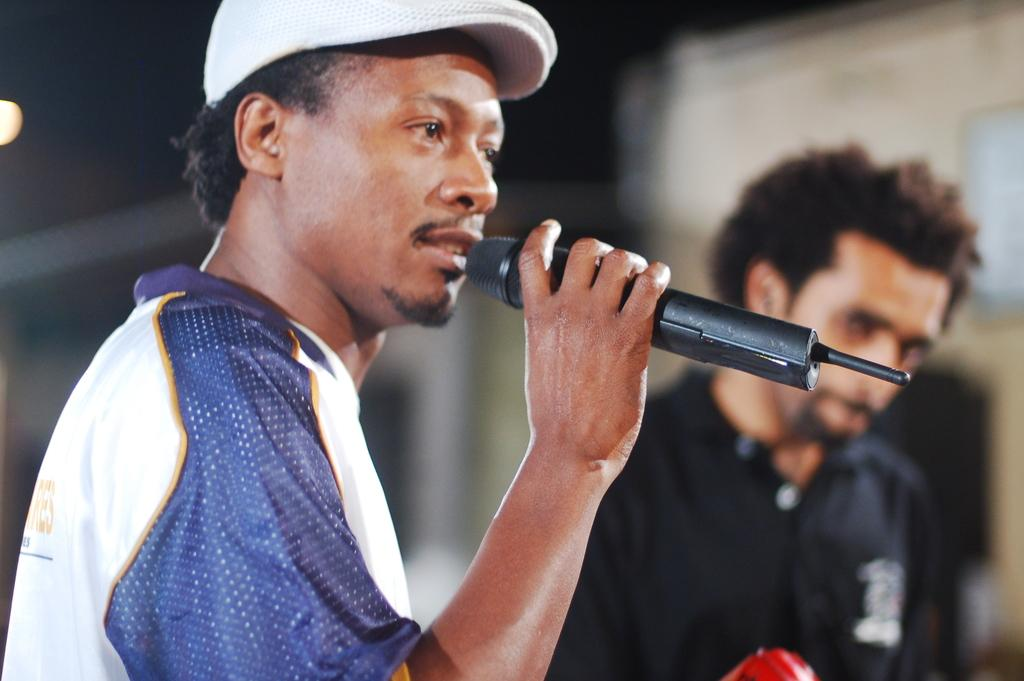How many people are in the image? There are two men in the image. What is one of the men holding in his hand? One man is holding a mic in his hand. What is the man with the mic doing? The man with the mic is talking. What is the other man doing in the image? The other man is looking at the man with the mic. Can you describe the background of the image? The background of the image is blurry. What book is the man with the mic reading in the image? There is no book present in the image, and the man with the mic is talking, not reading. 